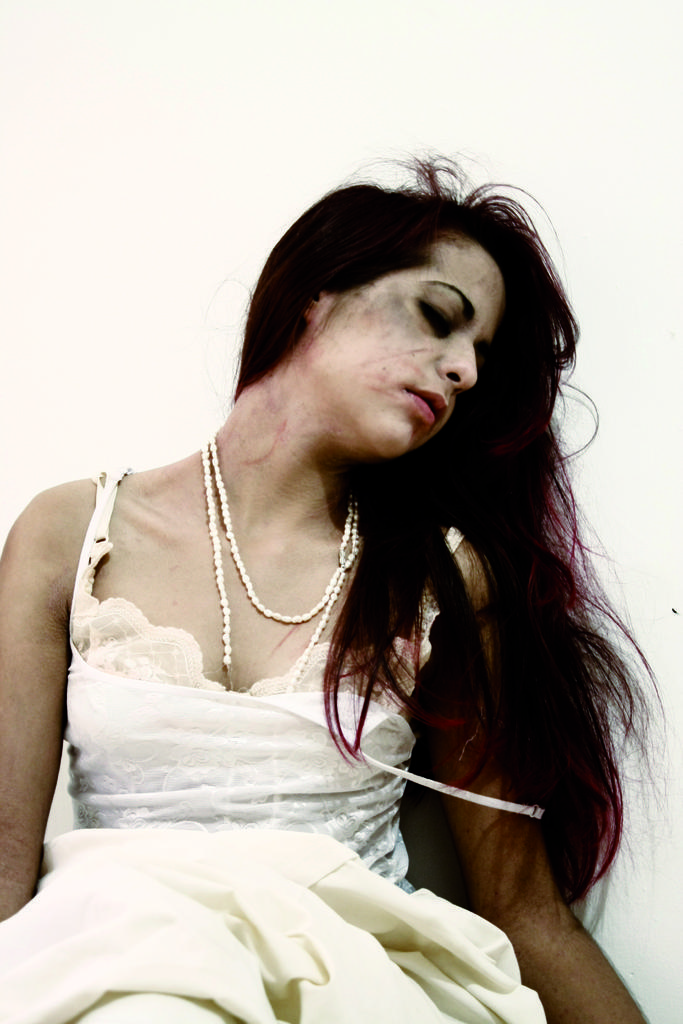Can you describe this image briefly? In the picture I can see a woman is wearing white color clothes. The background of the image is white in color. 